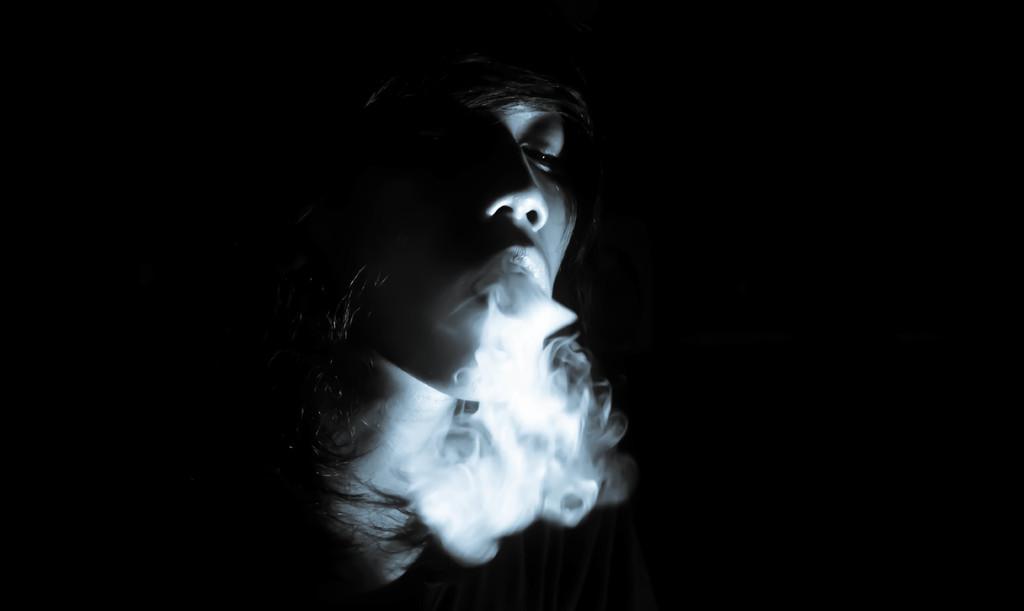Describe this image in one or two sentences. In this picture I can observe a person. I can observe smoke coming from the person's mouth. The background is completely dark. 